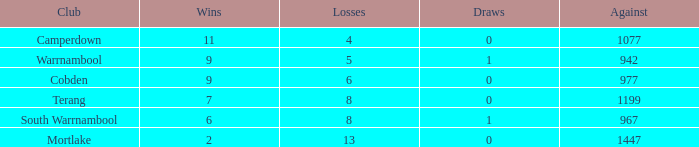How many draws occurred for mortlake when there were over 5 losses? 1.0. Give me the full table as a dictionary. {'header': ['Club', 'Wins', 'Losses', 'Draws', 'Against'], 'rows': [['Camperdown', '11', '4', '0', '1077'], ['Warrnambool', '9', '5', '1', '942'], ['Cobden', '9', '6', '0', '977'], ['Terang', '7', '8', '0', '1199'], ['South Warrnambool', '6', '8', '1', '967'], ['Mortlake', '2', '13', '0', '1447']]} 